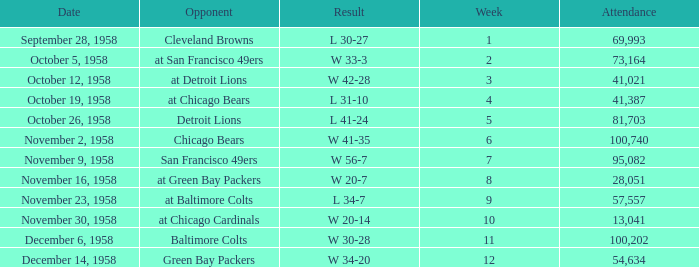What was the higest attendance on November 9, 1958? 95082.0. 